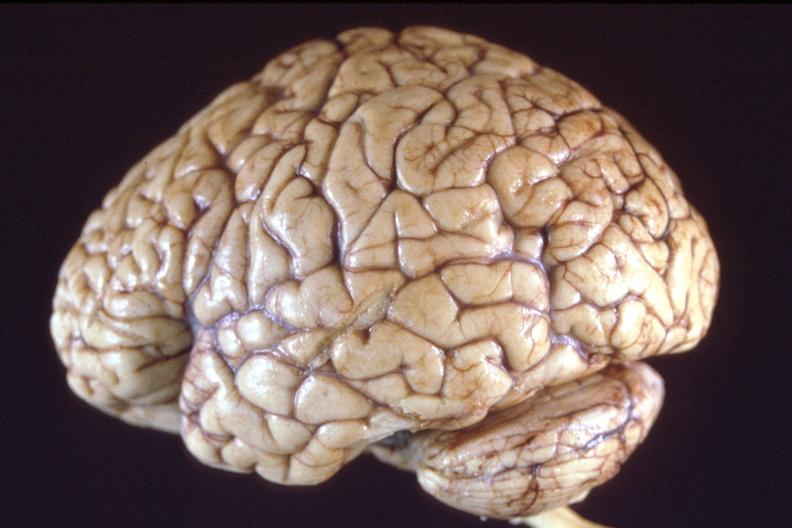does this image show brain, breast cancer metastasis to meninges?
Answer the question using a single word or phrase. Yes 